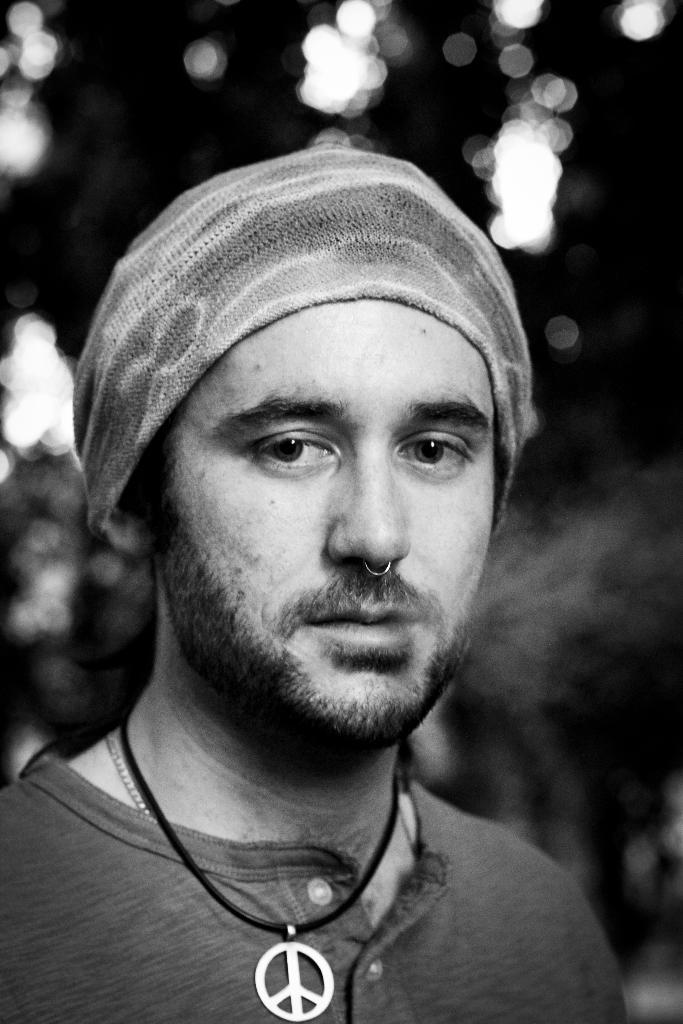What is the color scheme of the image? The image is black and white. What is the main subject of the image? There is a man in the image. What type of produce is being harvested in the image? There is no produce present in the image; it only features a man. What day of the week is it in the image? There is no calendar or indication of the day of the week in the image. 